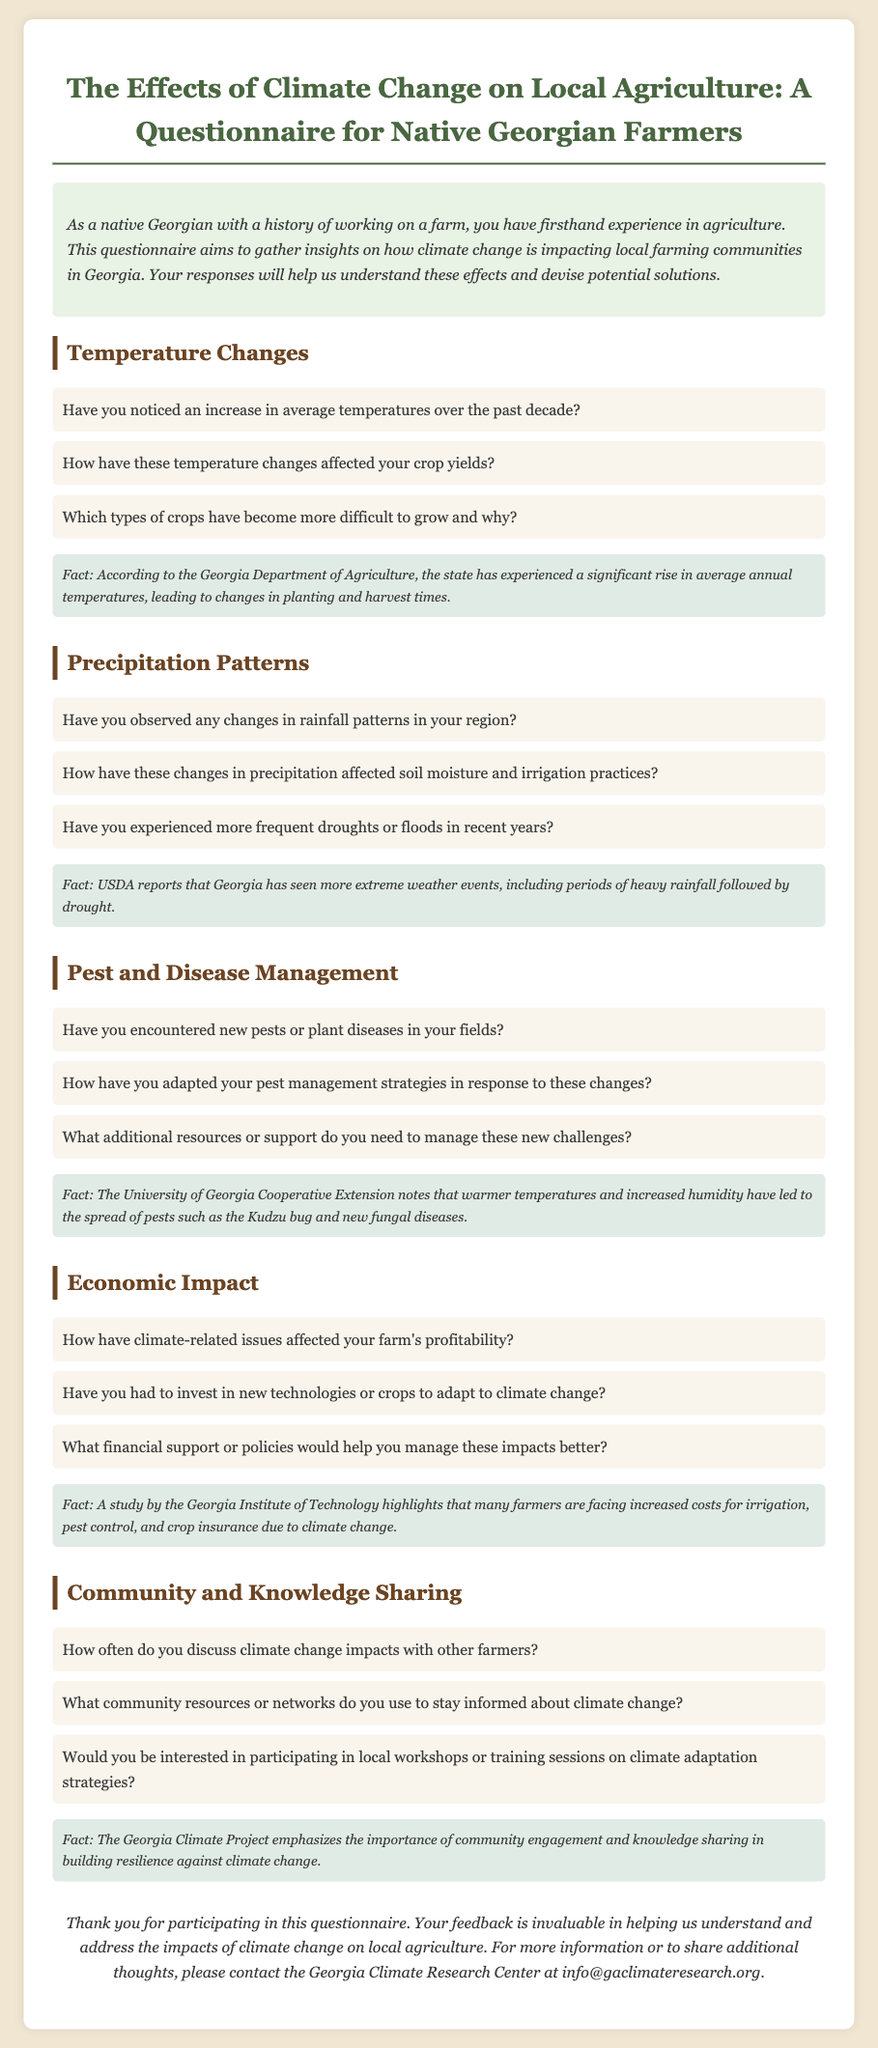What is the title of the questionnaire? The title of the questionnaire is found at the top of the document.
Answer: The Effects of Climate Change on Local Agriculture: A Questionnaire for Native Georgian Farmers How many sections are in the document? The document contains five distinct sections about various impacts.
Answer: Five What is one fact mentioned about temperature changes? A specific fact regarding temperature changes is provided in the fact box under the relevant section.
Answer: The state has experienced a significant rise in average annual temperatures What type of pests have been noted in the document? The questionnaire includes information about pests that have emerged as a concern in the agricultural landscape.
Answer: Kudzu bug According to the document, how often do farmers discuss climate change? The questionnaire asks this directly in the community and knowledge sharing section.
Answer: (Open-ended response; there is no specific answer in the document) What organization should be contacted for more information? The contact information at the end of the document provides the name of the organization.
Answer: Georgia Climate Research Center Which type of economic impact is mentioned in the document? The document discusses various economic impacts that may concern farmers.
Answer: Profitability What is the goal of this questionnaire? The aim of the questionnaire is outlined in the introductory paragraph.
Answer: Gather insights on how climate change is impacting local farming communities 